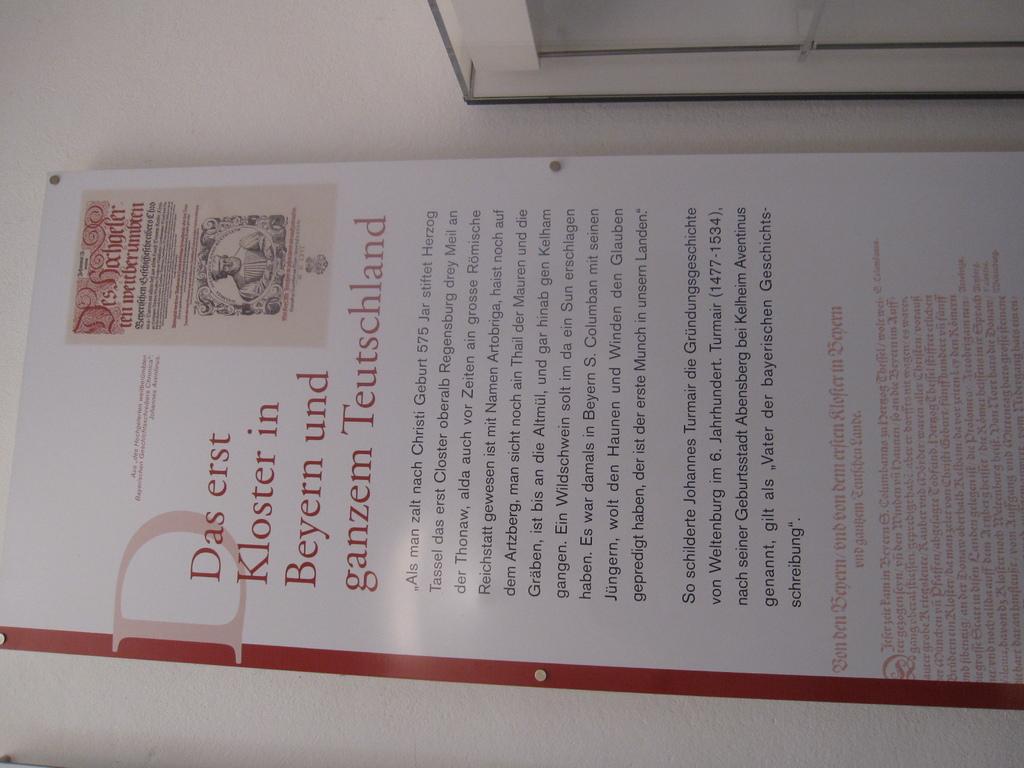What are the first two words of the title of this article?
Provide a short and direct response. Das erst. 